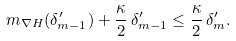Convert formula to latex. <formula><loc_0><loc_0><loc_500><loc_500>m _ { \nabla H } ( \delta ^ { \prime } _ { m - 1 } ) + \frac { \kappa } { 2 } \, \delta ^ { \prime } _ { m - 1 } \leq \frac { \kappa } { 2 } \, \delta ^ { \prime } _ { m } .</formula> 